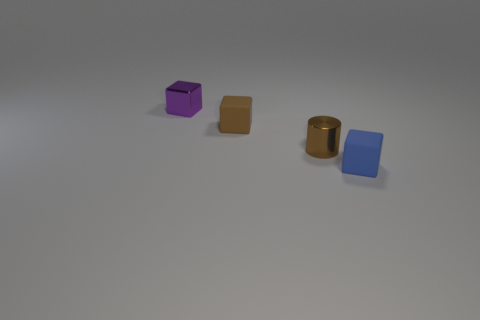Add 4 tiny blue objects. How many objects exist? 8 Subtract all blocks. How many objects are left? 1 Subtract 0 green blocks. How many objects are left? 4 Subtract all tiny brown metal cylinders. Subtract all tiny brown cubes. How many objects are left? 2 Add 1 metallic blocks. How many metallic blocks are left? 2 Add 2 tiny red cylinders. How many tiny red cylinders exist? 2 